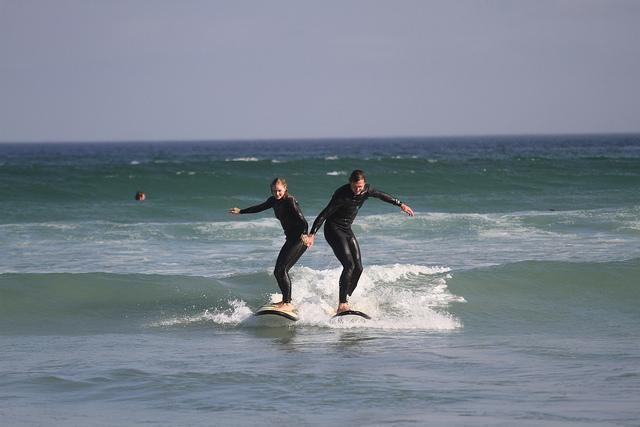How many women are surfing?
Give a very brief answer. 1. How many people can be seen?
Give a very brief answer. 2. How many brown horses are in the grass?
Give a very brief answer. 0. 